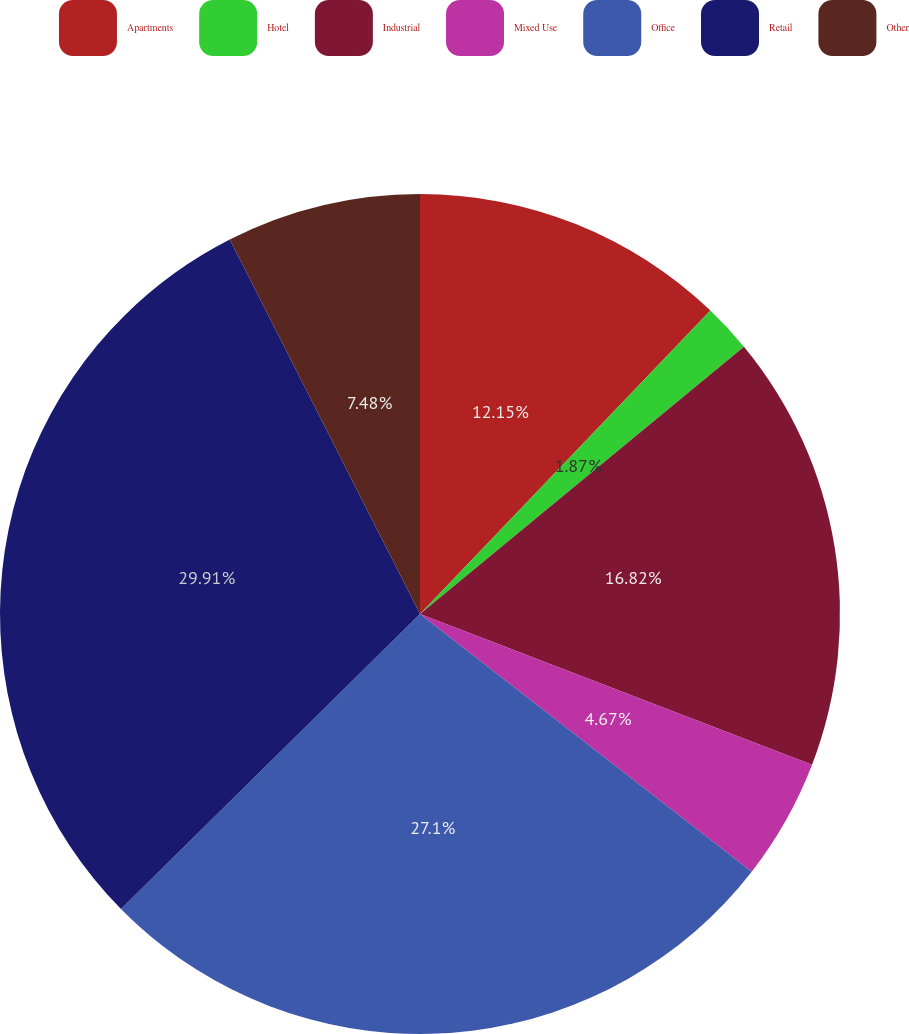Convert chart. <chart><loc_0><loc_0><loc_500><loc_500><pie_chart><fcel>Apartments<fcel>Hotel<fcel>Industrial<fcel>Mixed Use<fcel>Office<fcel>Retail<fcel>Other<nl><fcel>12.15%<fcel>1.87%<fcel>16.82%<fcel>4.67%<fcel>27.1%<fcel>29.91%<fcel>7.48%<nl></chart> 